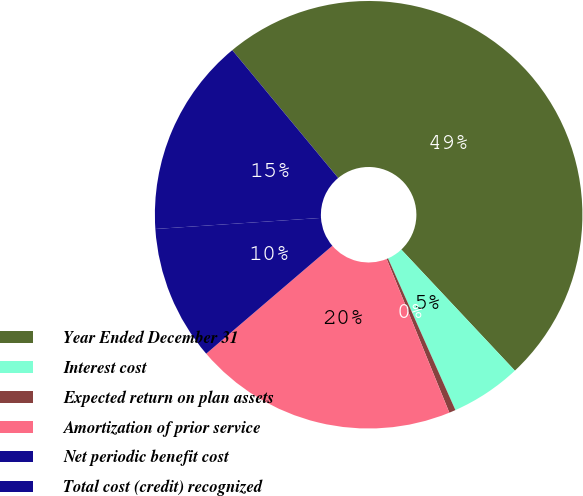Convert chart to OTSL. <chart><loc_0><loc_0><loc_500><loc_500><pie_chart><fcel>Year Ended December 31<fcel>Interest cost<fcel>Expected return on plan assets<fcel>Amortization of prior service<fcel>Net periodic benefit cost<fcel>Total cost (credit) recognized<nl><fcel>49.02%<fcel>5.34%<fcel>0.49%<fcel>19.9%<fcel>10.2%<fcel>15.05%<nl></chart> 